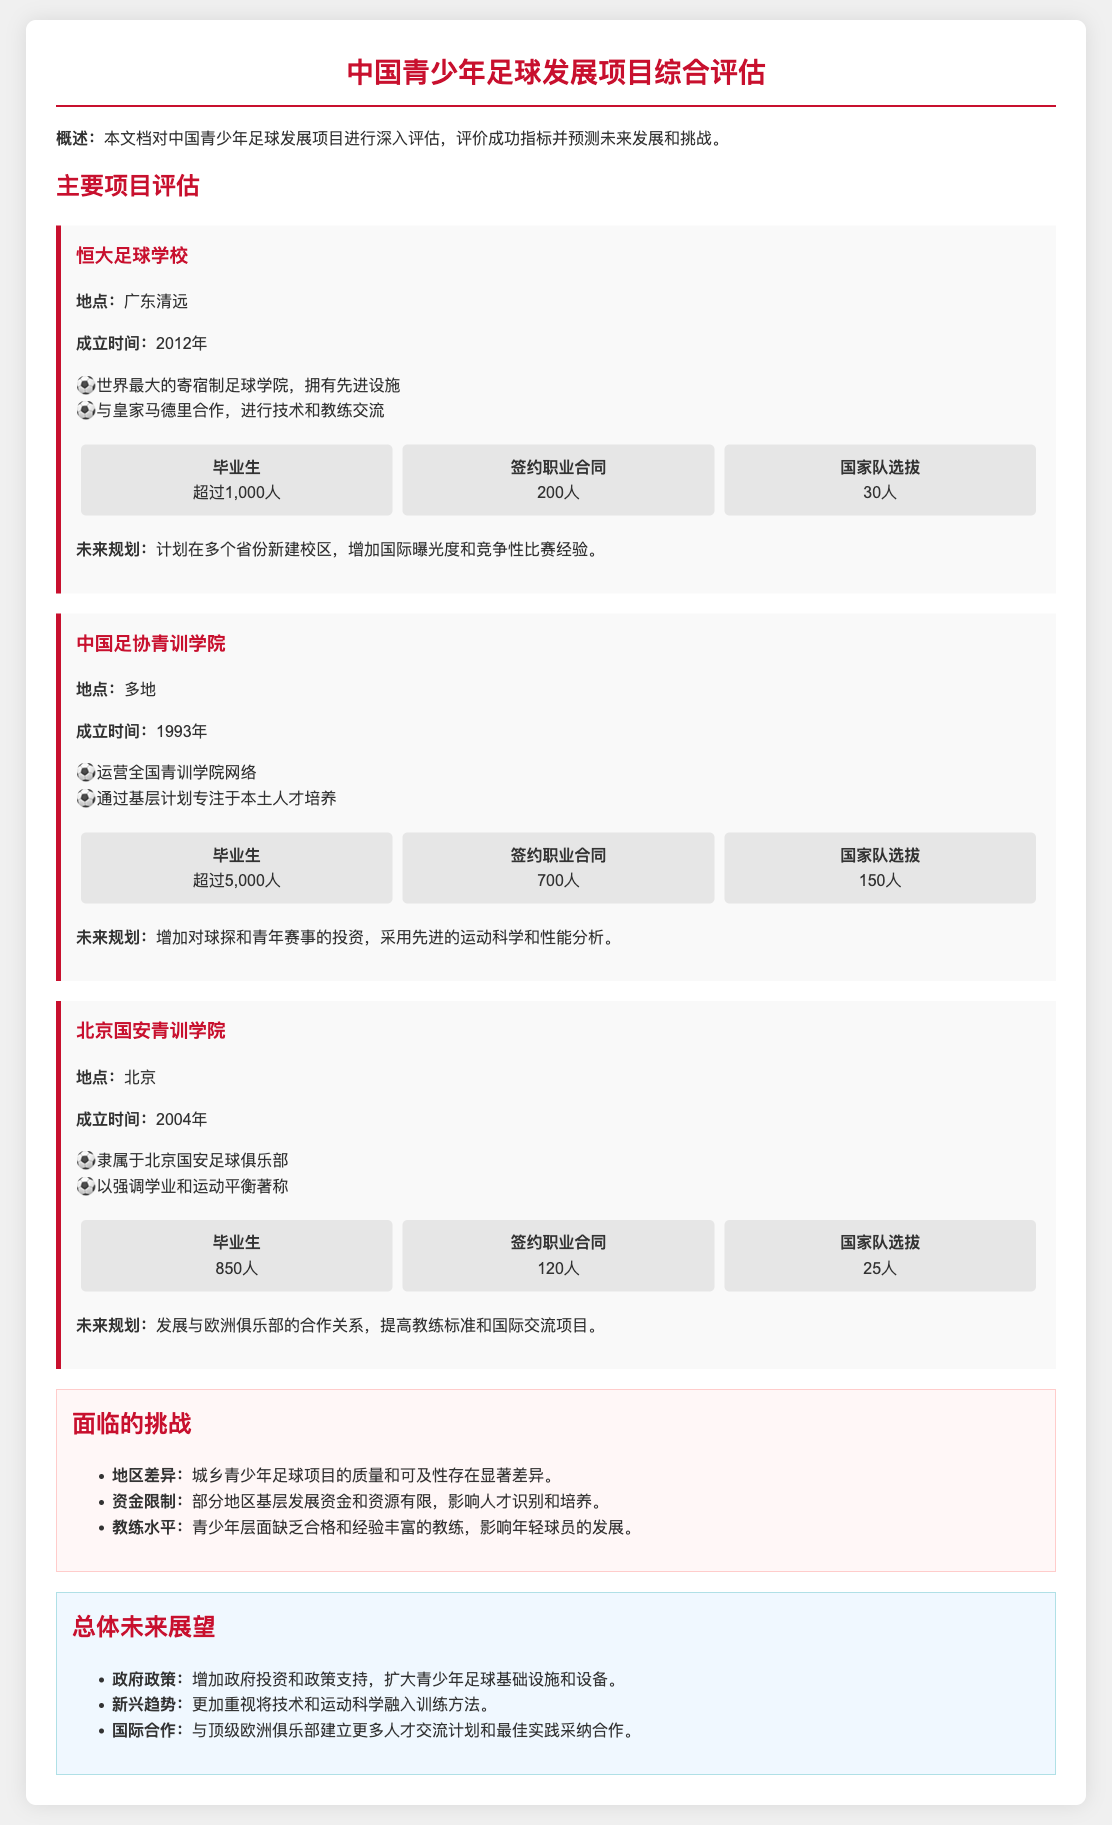What is the location of 恒大足球学校? The location of 恒大足球学校 is mentioned as 广东清远.
Answer: 广东清远 How many students have signed professional contracts from 中国足协青训学院? The number of students signed professional contracts from 中国足协青训学院 is provided as 700.
Answer: 700 What year was 北京国安青训学院 established? The year of establishment for 北京国安青训学院 is given as 2004.
Answer: 2004 How many graduates has 恒大足球学校 produced? The total number of graduates from 恒大足球学校 is stated as 超过1,000人.
Answer: 超过1,000人 What is a key challenge mentioned in the document? The document mentions several key challenges, one being the significant differences in quality and accessibility of youth soccer programs between urban and rural areas.
Answer: 地区差异 What is one of the future plans for 中国足协青训学院? The future plan for 中国足协青训学院 includes increasing investment in scouts and youth competitions.
Answer: 增加对球探和青年赛事的投资 What type of institution is 恒大足球学校? 恒大足球学校 is described as the world's largest boarding soccer academy.
Answer: 世界最大的寄宿制足球学院 What is the total number of players selected for the national team from 北京国安青训学院? The document states that 25 players have been selected for the national team from 北京国安青训学院.
Answer: 25人 What is the main focus of 中国足协青训学院? The main focus of 中国足协青训学院 is on nurturing local talent through grassroots programs.
Answer: 本土人才培养 